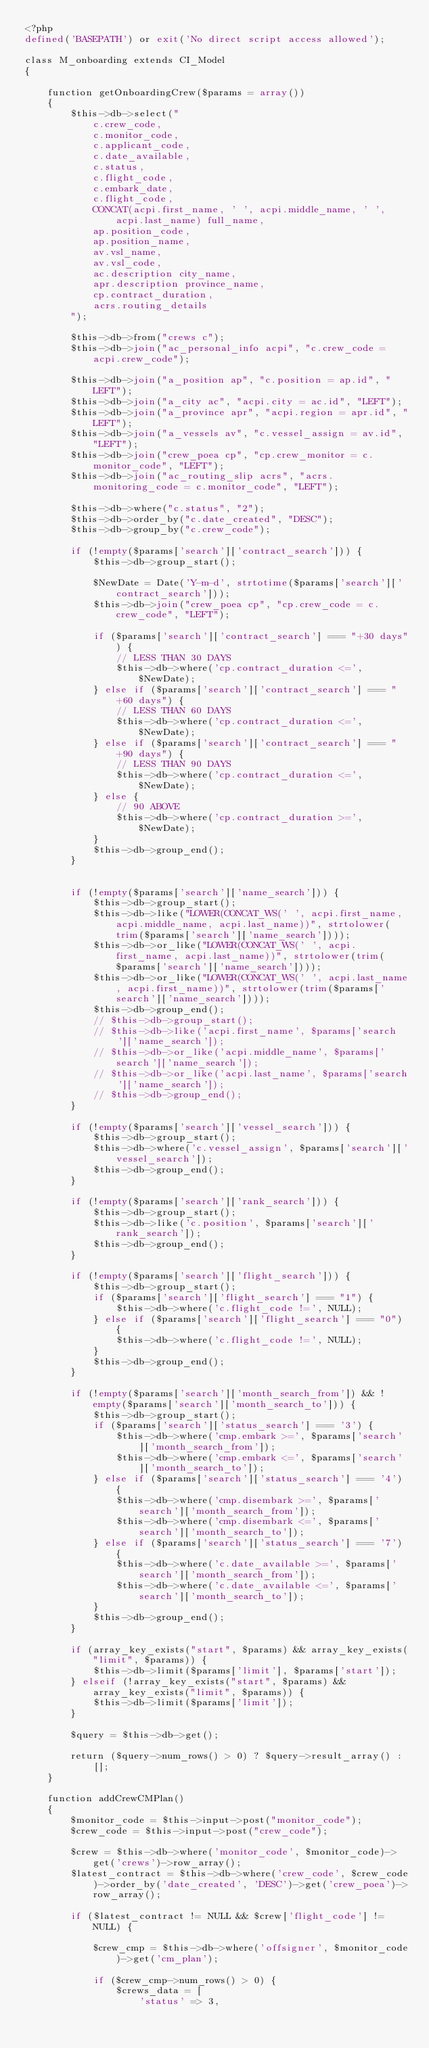<code> <loc_0><loc_0><loc_500><loc_500><_PHP_><?php
defined('BASEPATH') or exit('No direct script access allowed');

class M_onboarding extends CI_Model
{

    function getOnboardingCrew($params = array())
    {
        $this->db->select("
            c.crew_code,
            c.monitor_code,
            c.applicant_code,
            c.date_available,
            c.status,
            c.flight_code,
            c.embark_date,
            c.flight_code,
            CONCAT(acpi.first_name, ' ', acpi.middle_name, ' ', acpi.last_name) full_name,
            ap.position_code,
            ap.position_name,
            av.vsl_name,
            av.vsl_code,
            ac.description city_name,
            apr.description province_name,
            cp.contract_duration,
            acrs.routing_details
        ");

        $this->db->from("crews c");
        $this->db->join("ac_personal_info acpi", "c.crew_code = acpi.crew_code");

        $this->db->join("a_position ap", "c.position = ap.id", "LEFT");
        $this->db->join("a_city ac", "acpi.city = ac.id", "LEFT");
        $this->db->join("a_province apr", "acpi.region = apr.id", "LEFT");
        $this->db->join("a_vessels av", "c.vessel_assign = av.id", "LEFT");
        $this->db->join("crew_poea cp", "cp.crew_monitor = c.monitor_code", "LEFT");
        $this->db->join("ac_routing_slip acrs", "acrs.monitoring_code = c.monitor_code", "LEFT");

        $this->db->where("c.status", "2");
        $this->db->order_by("c.date_created", "DESC");
        $this->db->group_by("c.crew_code");

        if (!empty($params['search']['contract_search'])) {
            $this->db->group_start();

            $NewDate = Date('Y-m-d', strtotime($params['search']['contract_search']));
            $this->db->join("crew_poea cp", "cp.crew_code = c.crew_code", "LEFT");

            if ($params['search']['contract_search'] === "+30 days") {
                // LESS THAN 30 DAYS
                $this->db->where('cp.contract_duration <=', $NewDate);
            } else if ($params['search']['contract_search'] === "+60 days") {
                // LESS THAN 60 DAYS
                $this->db->where('cp.contract_duration <=', $NewDate);
            } else if ($params['search']['contract_search'] === "+90 days") {
                // LESS THAN 90 DAYS
                $this->db->where('cp.contract_duration <=', $NewDate);
            } else {
                // 90 ABOVE
                $this->db->where('cp.contract_duration >=', $NewDate);
            }
            $this->db->group_end();
        }


        if (!empty($params['search']['name_search'])) {
            $this->db->group_start();
            $this->db->like("LOWER(CONCAT_WS(' ', acpi.first_name, acpi.middle_name, acpi.last_name))", strtolower(trim($params['search']['name_search'])));
            $this->db->or_like("LOWER(CONCAT_WS(' ', acpi.first_name, acpi.last_name))", strtolower(trim($params['search']['name_search'])));
            $this->db->or_like("LOWER(CONCAT_WS(' ', acpi.last_name, acpi.first_name))", strtolower(trim($params['search']['name_search'])));
            $this->db->group_end();
            // $this->db->group_start();
            // $this->db->like('acpi.first_name', $params['search']['name_search']);
            // $this->db->or_like('acpi.middle_name', $params['search']['name_search']);
            // $this->db->or_like('acpi.last_name', $params['search']['name_search']);
            // $this->db->group_end();
        }

        if (!empty($params['search']['vessel_search'])) {
            $this->db->group_start();
            $this->db->where('c.vessel_assign', $params['search']['vessel_search']);
            $this->db->group_end();
        }

        if (!empty($params['search']['rank_search'])) {
            $this->db->group_start();
            $this->db->like('c.position', $params['search']['rank_search']);
            $this->db->group_end();
        }

        if (!empty($params['search']['flight_search'])) {
            $this->db->group_start();
            if ($params['search']['flight_search'] === "1") {
                $this->db->where('c.flight_code !=', NULL);
            } else if ($params['search']['flight_search'] === "0") {
                $this->db->where('c.flight_code !=', NULL);
            }
            $this->db->group_end();
        }

        if (!empty($params['search']['month_search_from']) && !empty($params['search']['month_search_to'])) {
            $this->db->group_start();
            if ($params['search']['status_search'] === '3') {
                $this->db->where('cmp.embark >=', $params['search']['month_search_from']);
                $this->db->where('cmp.embark <=', $params['search']['month_search_to']);
            } else if ($params['search']['status_search'] === '4') {
                $this->db->where('cmp.disembark >=', $params['search']['month_search_from']);
                $this->db->where('cmp.disembark <=', $params['search']['month_search_to']);
            } else if ($params['search']['status_search'] === '7') {
                $this->db->where('c.date_available >=', $params['search']['month_search_from']);
                $this->db->where('c.date_available <=', $params['search']['month_search_to']);
            }
            $this->db->group_end();
        }

        if (array_key_exists("start", $params) && array_key_exists("limit", $params)) {
            $this->db->limit($params['limit'], $params['start']);
        } elseif (!array_key_exists("start", $params) && array_key_exists("limit", $params)) {
            $this->db->limit($params['limit']);
        }

        $query = $this->db->get();

        return ($query->num_rows() > 0) ? $query->result_array() : [];
    }

    function addCrewCMPlan()
    {
        $monitor_code = $this->input->post("monitor_code");
        $crew_code = $this->input->post("crew_code");

        $crew = $this->db->where('monitor_code', $monitor_code)->get('crews')->row_array();
        $latest_contract = $this->db->where('crew_code', $crew_code)->order_by('date_created', 'DESC')->get('crew_poea')->row_array();

        if ($latest_contract != NULL && $crew['flight_code'] != NULL) {

            $crew_cmp = $this->db->where('offsigner', $monitor_code)->get('cm_plan');

            if ($crew_cmp->num_rows() > 0) {
                $crews_data = [
                    'status' => 3,</code> 